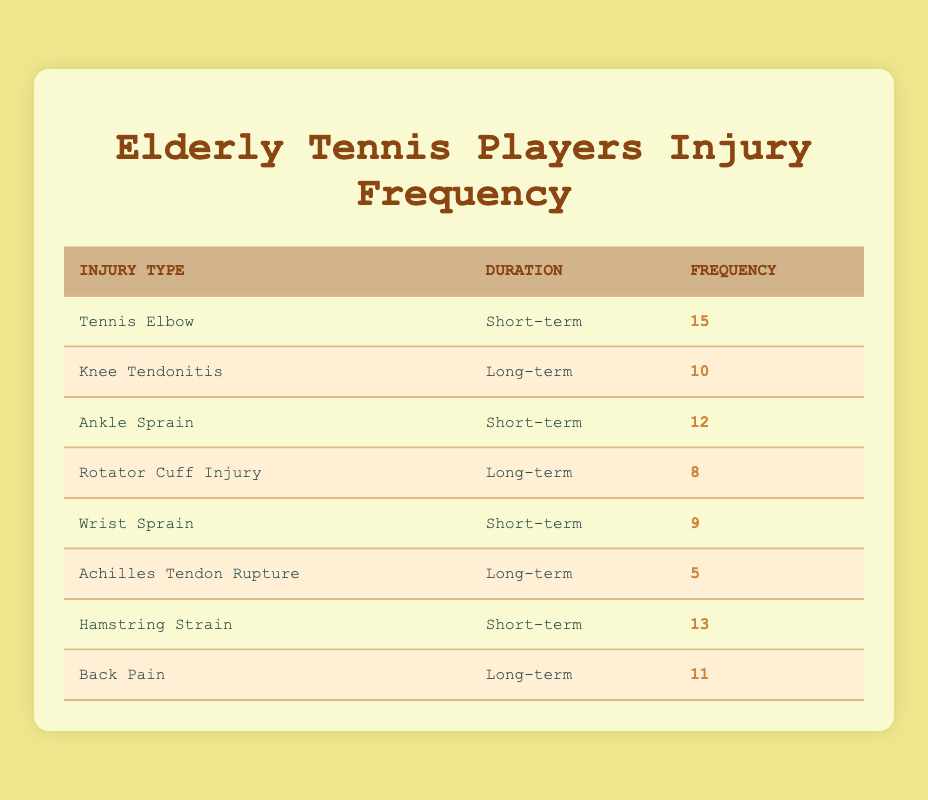What is the frequency of Tennis Elbow injuries among elderly tennis players? From the table, we can see that the frequency of Tennis Elbow injuries is listed directly under the "Frequency" column for that particular type of injury. It shows 15 occurrences.
Answer: 15 How many total long-term injuries are documented in the table? To find the total long-term injuries, we need to sum the frequencies of injuries categorized as long-term. The long-term injuries are Knee Tendonitis (10), Rotator Cuff Injury (8), and Back Pain (11). Summing these gives us 10 + 8 + 11 = 29.
Answer: 29 Is the frequency of Ankle Sprain injuries greater than that of Wrist Sprain injuries? In the table, the frequency for Ankle Sprain is 12 and for Wrist Sprain is 9. Since 12 is greater than 9, we can conclude that the frequency of Ankle Sprain injuries is indeed greater.
Answer: Yes What is the average frequency of short-term injuries listed in the table? First, we identify the short-term injuries and their frequencies: Tennis Elbow (15), Ankle Sprain (12), Wrist Sprain (9), and Hamstring Strain (13). Summing these gives us 15 + 12 + 9 + 13 = 49. Since there are 4 short-term injuries, we divide 49 by 4, which gives us an average of 12.25.
Answer: 12.25 Which type of injury has the highest frequency, and what is that frequency? By reviewing the frequencies across all types of injuries in the table, we find that Tennis Elbow has a frequency of 15, which is the highest compared to other entries.
Answer: Tennis Elbow; 15 Are there more short-term injuries than long-term injuries combined? First, we sum the frequencies of short-term injuries: Tennis Elbow (15), Ankle Sprain (12), Wrist Sprain (9), and Hamstring Strain (13) gives us 15 + 12 + 9 + 13 = 49. Next, for long-term injuries, we sum Knee Tendonitis (10), Rotator Cuff Injury (8), Achilles Tendon Rupture (5), and Back Pain (11), which gives us 10 + 8 + 5 + 11 = 34. Comparing the two sums, 49 is greater than 34.
Answer: Yes What is the least frequent long-term injury and its frequency? By checking the frequencies under the long-term category, we see Knee Tendonitis (10), Rotator Cuff Injury (8), Achilles Tendon Rupture (5), and Back Pain (11). The least frequent among these is Achilles Tendon Rupture at 5 occurrences.
Answer: Achilles Tendon Rupture; 5 How many more short-term injuries are there compared to long-term injuries? To find this, we first calculate the total number of short-term injuries, which is 49, and the total number of long-term injuries, which is 34. The difference is calculated by subtracting the long-term total from the short-term total: 49 - 34 = 15.
Answer: 15 